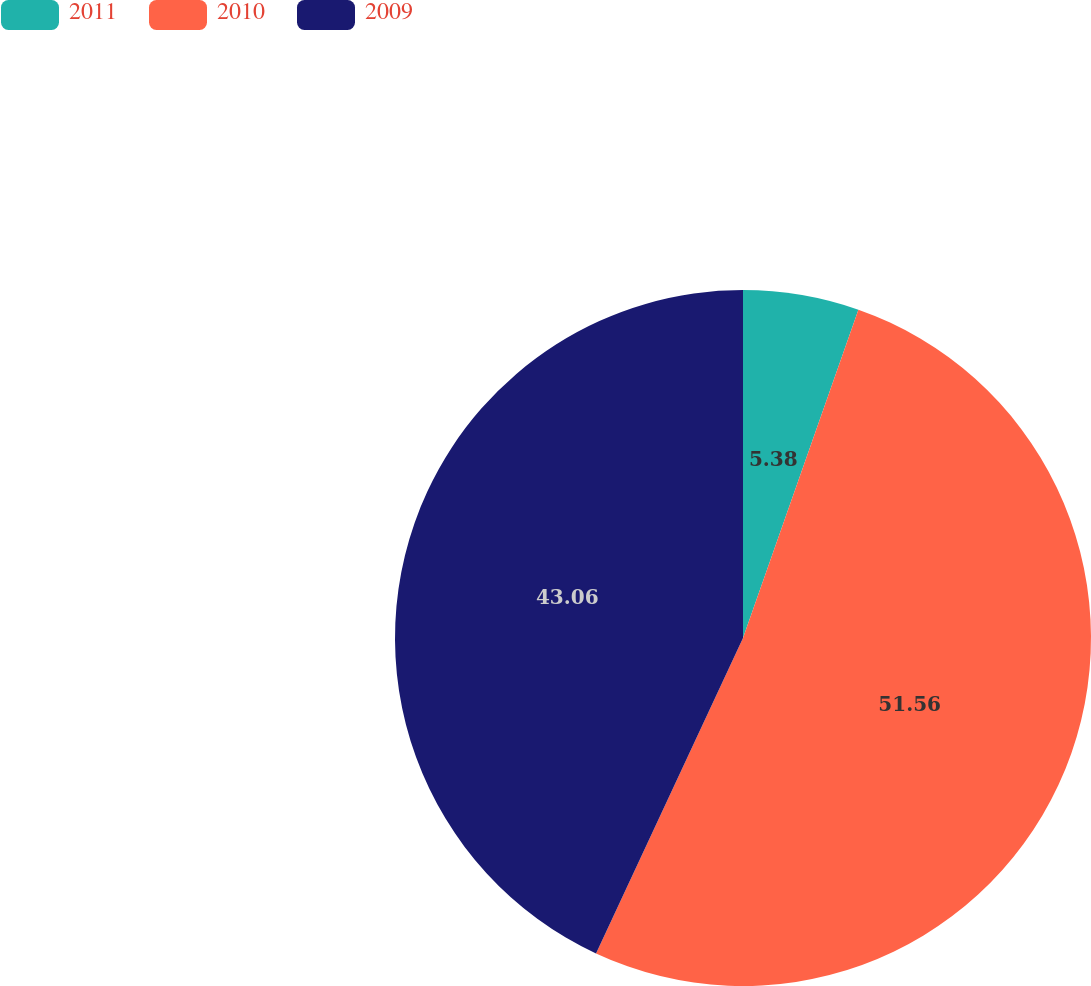Convert chart to OTSL. <chart><loc_0><loc_0><loc_500><loc_500><pie_chart><fcel>2011<fcel>2010<fcel>2009<nl><fcel>5.38%<fcel>51.56%<fcel>43.06%<nl></chart> 